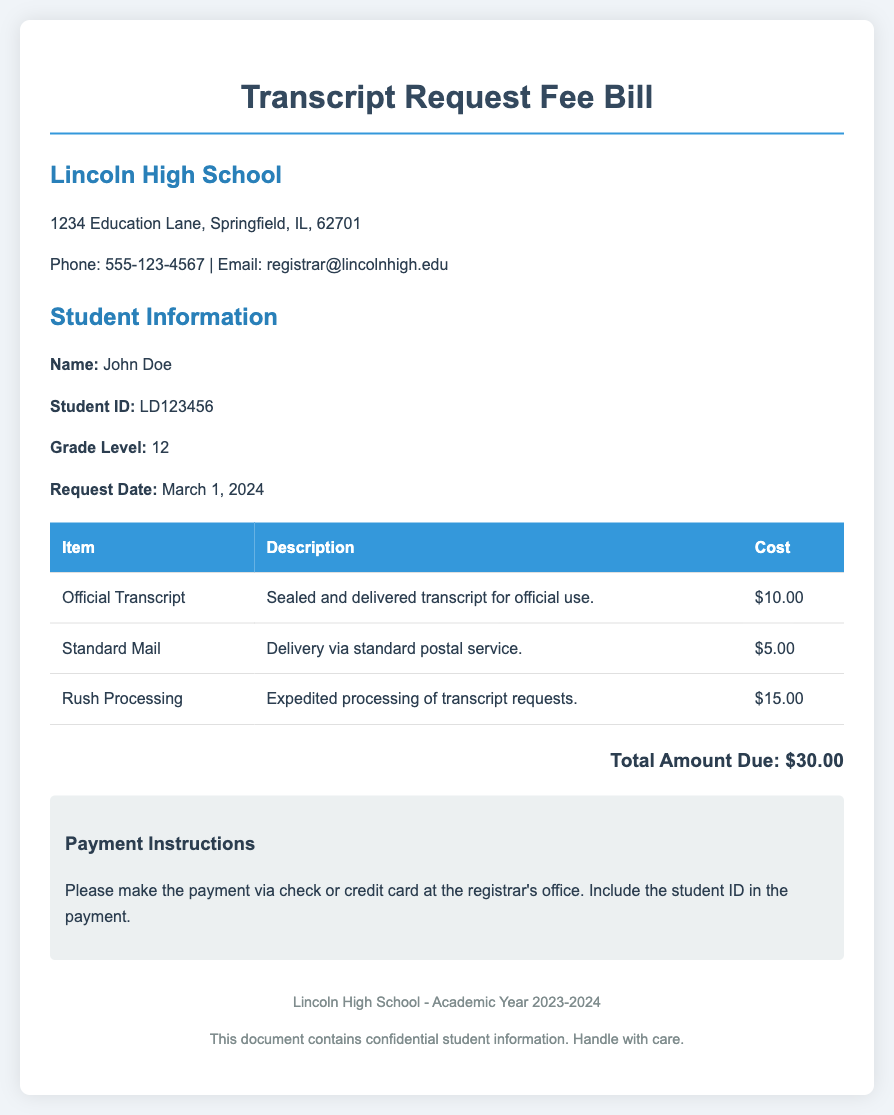what is the name of the student? The student's name is clearly stated in the student information section.
Answer: John Doe what is the student ID? The student ID is listed below the student's name in the document.
Answer: LD123456 what is the cost of the official transcript? The document specifies the charge for the official transcript in the itemized costs table.
Answer: $10.00 what is the total amount due? The total due is mentioned at the bottom of the document after summing the costs of all requested items.
Answer: $30.00 how much does rush processing cost? The cost of rush processing is detailed in the itemized costs section.
Answer: $15.00 what delivery method costs $5.00? The document describes different delivery methods, and the standard mail cost is highlighted.
Answer: Standard Mail what date was the request made? The request date is included in the student information section of the document.
Answer: March 1, 2024 who should payments be made to? The payment instructions clarify where payments should be directed.
Answer: registrar's office what is the address of Lincoln High School? The address of the school is provided in the school information section of the document.
Answer: 1234 Education Lane, Springfield, IL, 62701 